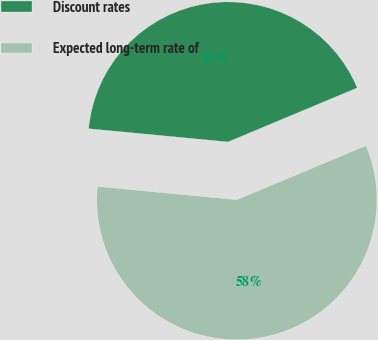Convert chart to OTSL. <chart><loc_0><loc_0><loc_500><loc_500><pie_chart><fcel>Discount rates<fcel>Expected long-term rate of<nl><fcel>42.18%<fcel>57.82%<nl></chart> 